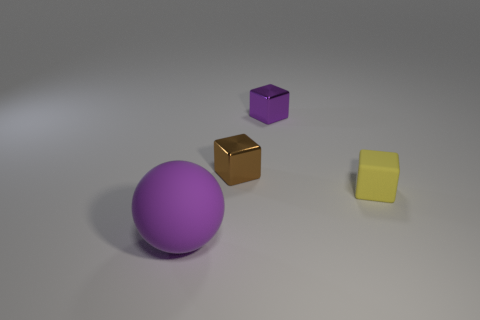The tiny object that is the same color as the large matte ball is what shape?
Give a very brief answer. Cube. Is the number of metal things greater than the number of cubes?
Your answer should be compact. No. What is the small purple cube made of?
Your answer should be compact. Metal. How many other things are made of the same material as the small brown cube?
Offer a terse response. 1. What number of purple shiny objects are there?
Offer a very short reply. 1. There is a small brown thing that is the same shape as the tiny purple metallic object; what is its material?
Offer a terse response. Metal. Is the purple object behind the large purple sphere made of the same material as the large sphere?
Provide a succinct answer. No. Is the number of big things left of the tiny purple object greater than the number of brown blocks right of the small brown metallic cube?
Ensure brevity in your answer.  Yes. The purple block has what size?
Make the answer very short. Small. There is a thing that is the same material as the purple block; what is its shape?
Provide a short and direct response. Cube. 